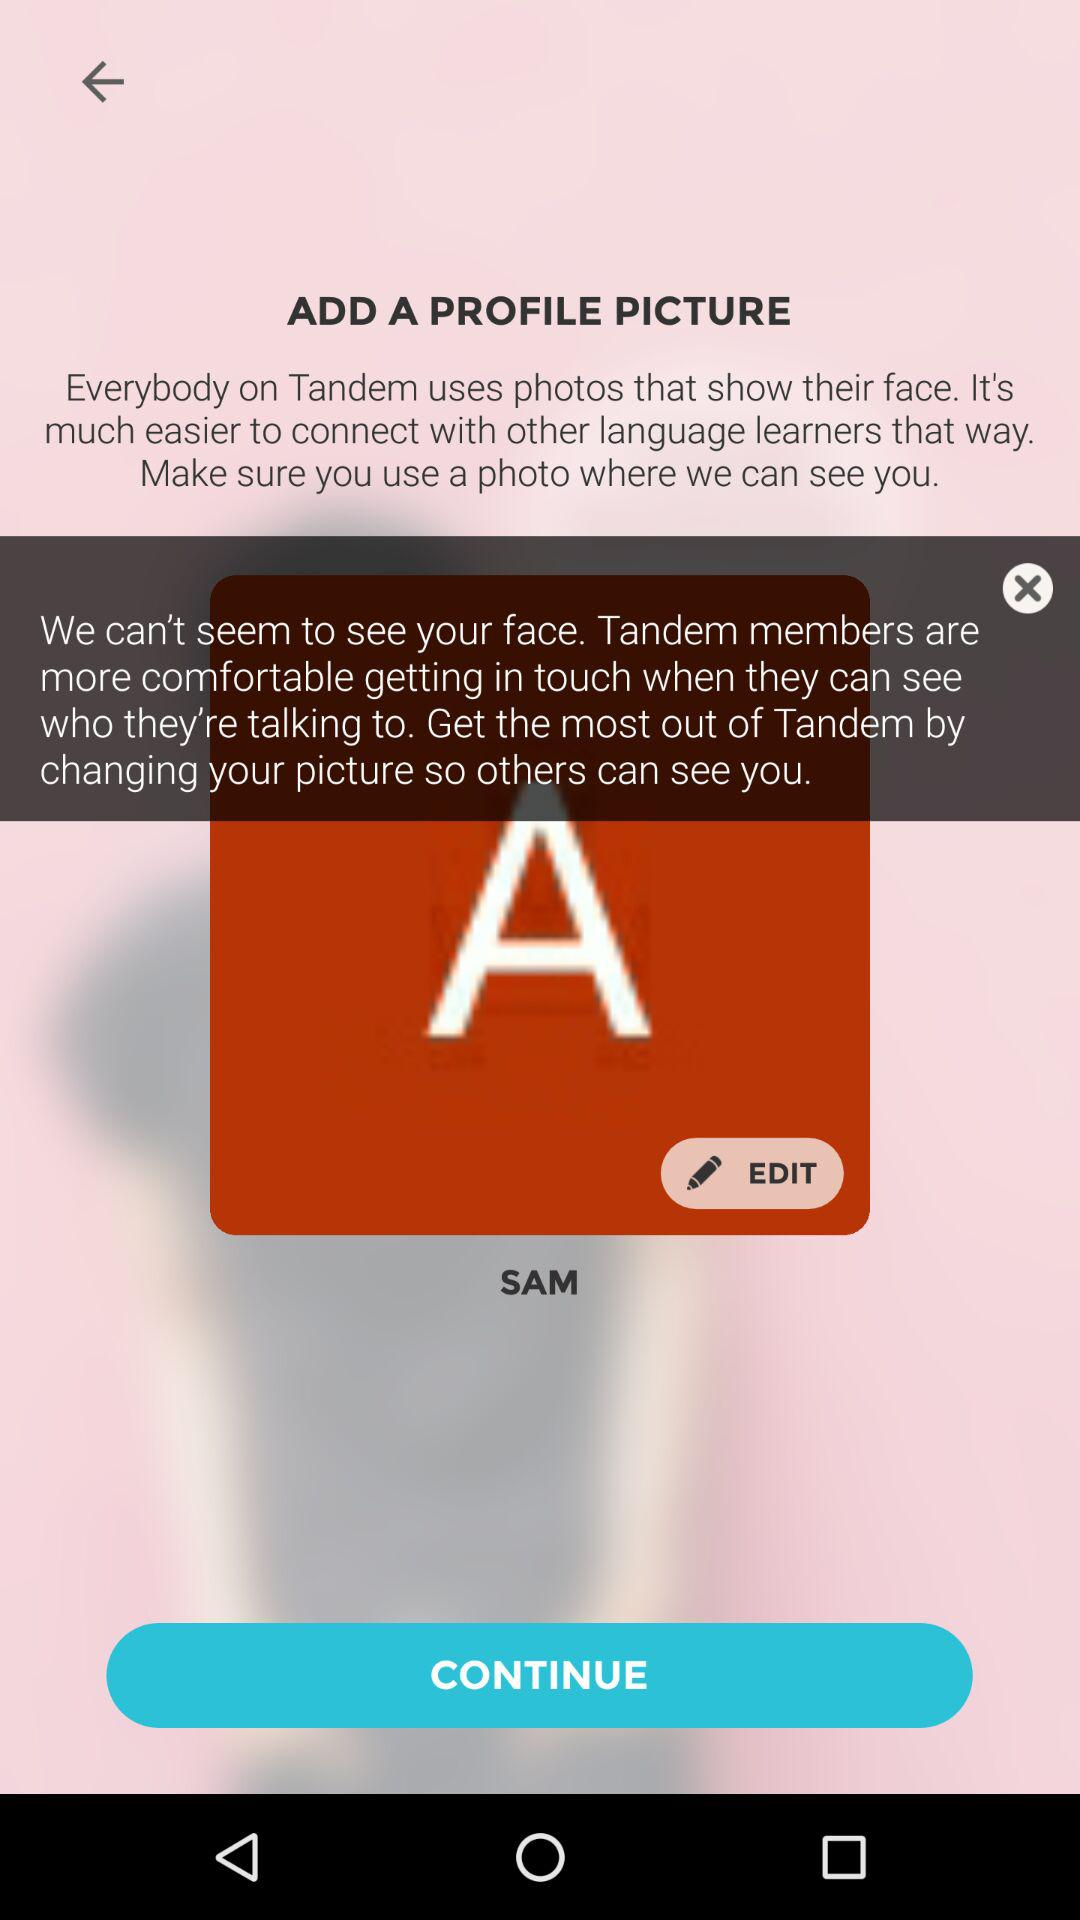What is the user name? The user name is SAM. 